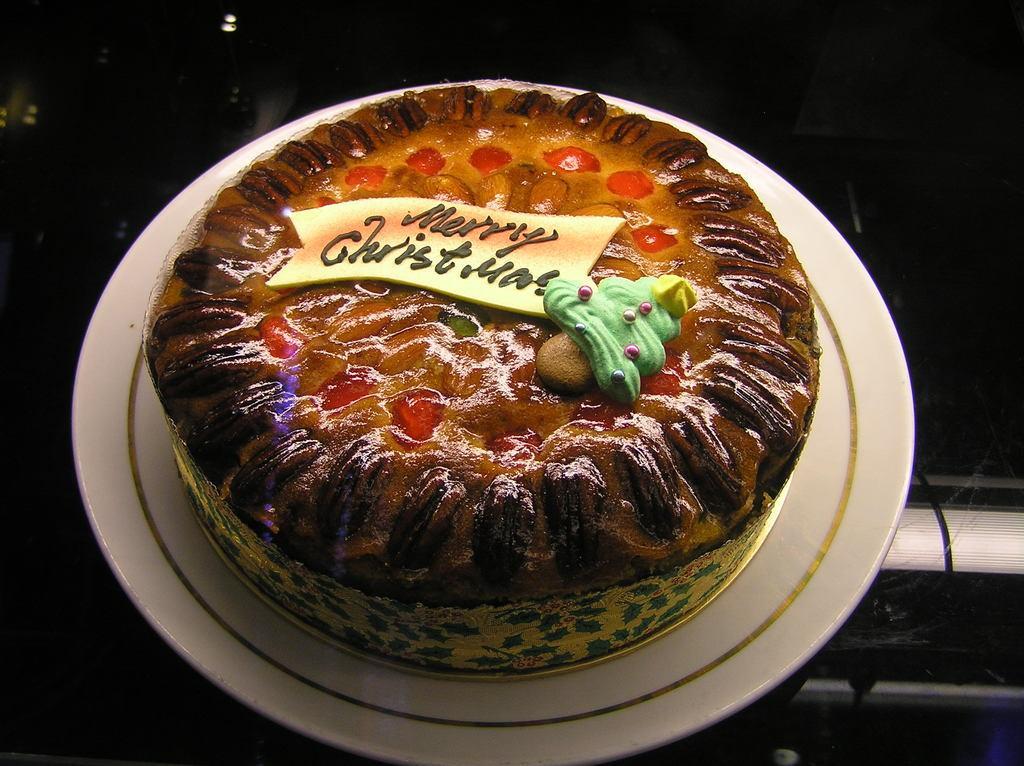Could you give a brief overview of what you see in this image? There is a white plate on a surface. On the plate there is a cake with something written on that.. 